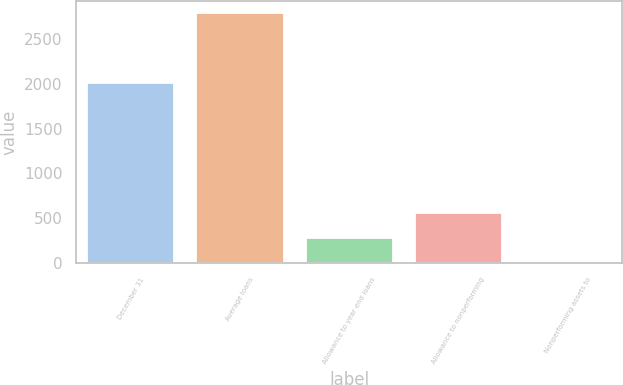<chart> <loc_0><loc_0><loc_500><loc_500><bar_chart><fcel>December 31<fcel>Average loans<fcel>Allowance to year end loans<fcel>Allowance to nonperforming<fcel>Nonperforming assets to<nl><fcel>2007<fcel>2786<fcel>278.73<fcel>557.32<fcel>0.14<nl></chart> 